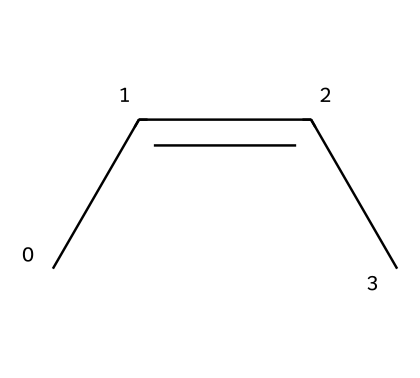What is the molecular formula of cis-2-butene? Counting the carbon and hydrogen atoms in the structure gives us 4 carbons and 8 hydrogens, making the molecular formula C4H8.
Answer: C4H8 How many double bonds are present in cis-2-butene? The chemical structure shows one double bond between the two carbon atoms, indicated by the C=C part.
Answer: 1 What is the name of this geometric isomer? The specific arrangement of the substituents on the double bond identifies it as cis-2-butene, where the two methyl groups are on the same side.
Answer: cis-2-butene What type of isomerism does cis-2-butene exhibit? This compound shows geometric (cis-trans) isomerism due to the restricted rotation around the double bond and the different spatial arrangements of the groups.
Answer: geometric isomerism How many hydrogen atoms are attached to each carbon in the double bond? Each carbon involved in the double bond has one hydrogen atom due to double bonding to another carbon, so there is 1 hydrogen on each.
Answer: 1 Why is cis-2-butene considered more polar than its trans counterpart? The spatial arrangement of the same side contributing methyl groups in cis-2-butene causes a net dipole moment, making it more polar compared to trans-2-butene.
Answer: more polar 